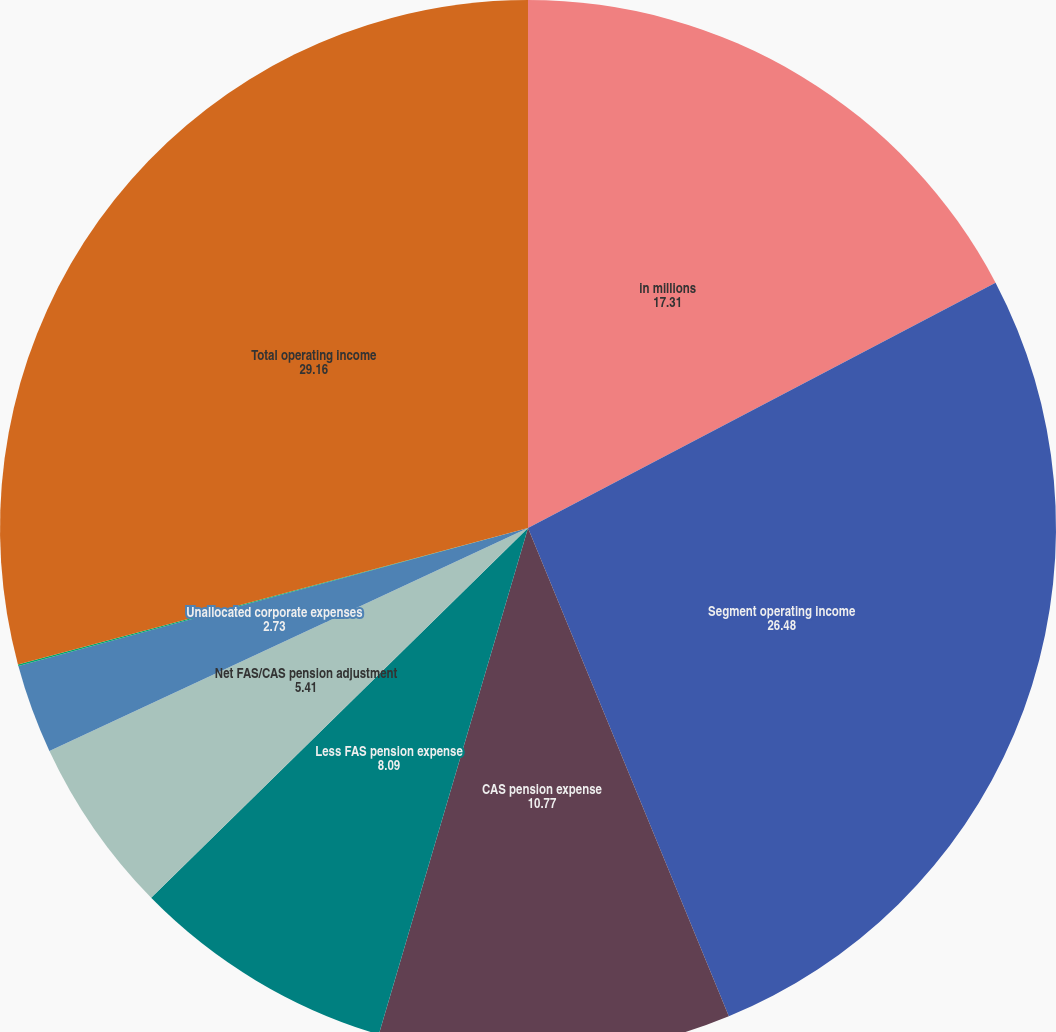Convert chart. <chart><loc_0><loc_0><loc_500><loc_500><pie_chart><fcel>in millions<fcel>Segment operating income<fcel>CAS pension expense<fcel>Less FAS pension expense<fcel>Net FAS/CAS pension adjustment<fcel>Unallocated corporate expenses<fcel>Other<fcel>Total operating income<nl><fcel>17.31%<fcel>26.48%<fcel>10.77%<fcel>8.09%<fcel>5.41%<fcel>2.73%<fcel>0.05%<fcel>29.16%<nl></chart> 